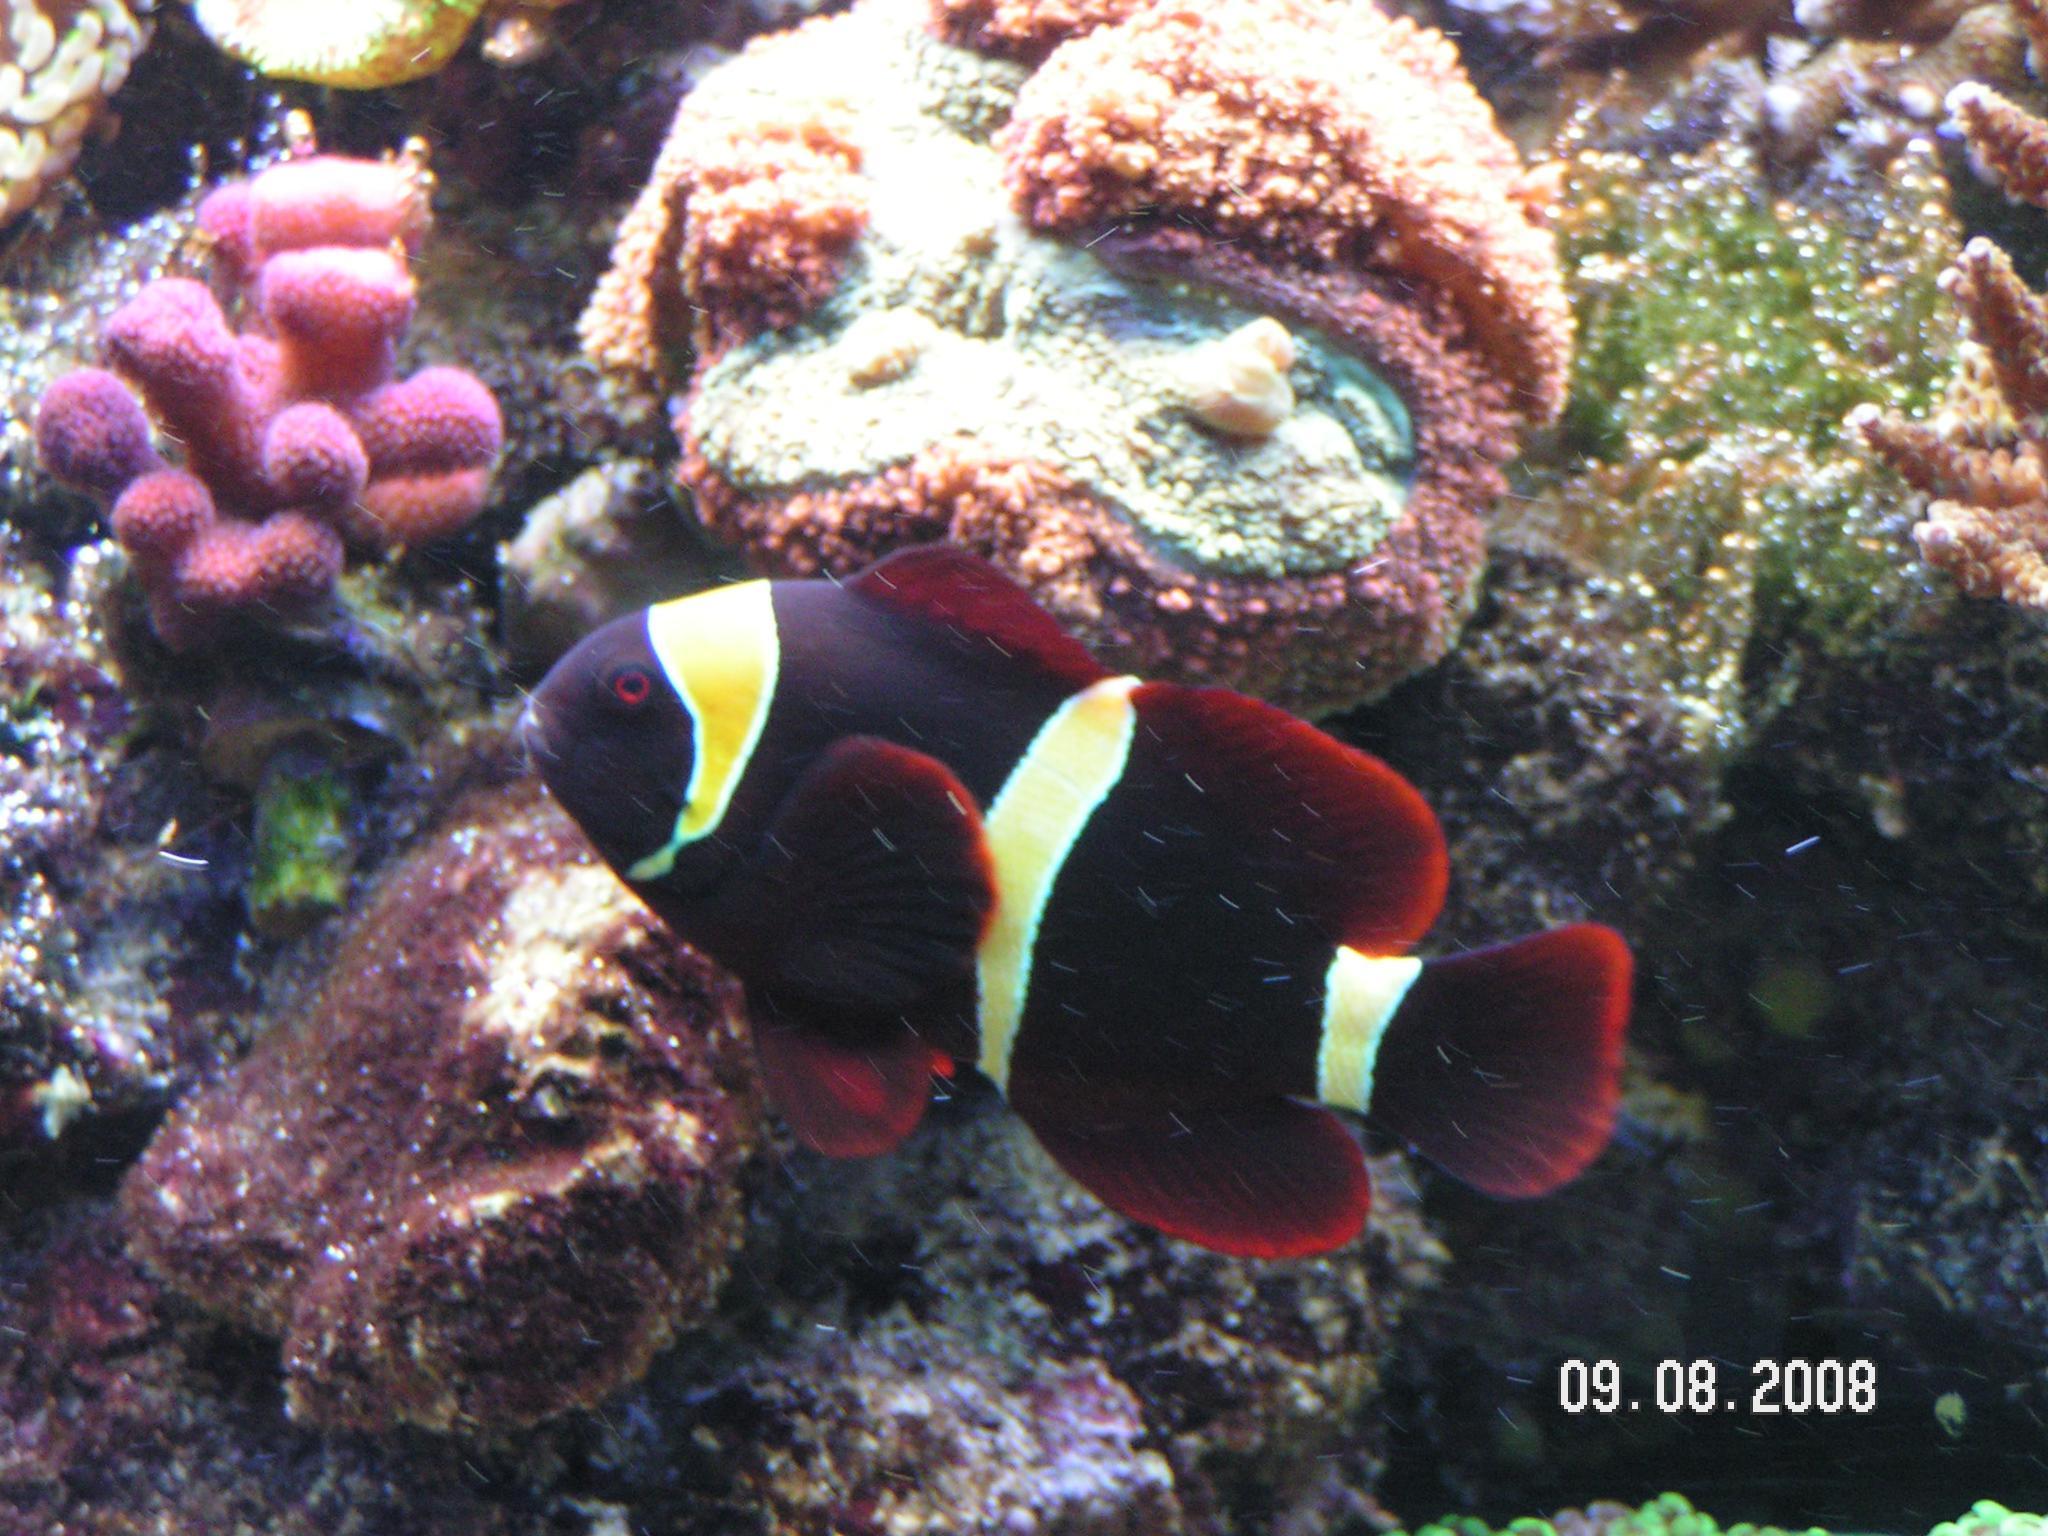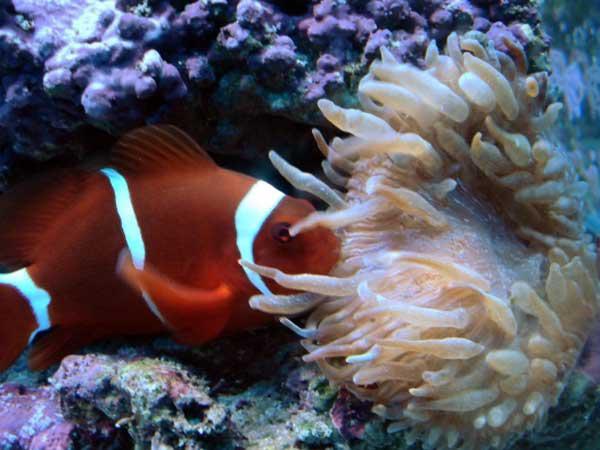The first image is the image on the left, the second image is the image on the right. For the images shown, is this caption "The clownfish in the left image is not actually within the anemone right now." true? Answer yes or no. Yes. 